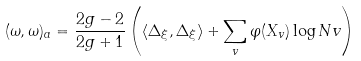<formula> <loc_0><loc_0><loc_500><loc_500>( \omega , \omega ) _ { a } = \frac { 2 g - 2 } { 2 g + 1 } \left ( \langle \Delta _ { \xi } , \Delta _ { \xi } \rangle + \sum _ { v } \varphi ( X _ { v } ) \log N v \right )</formula> 